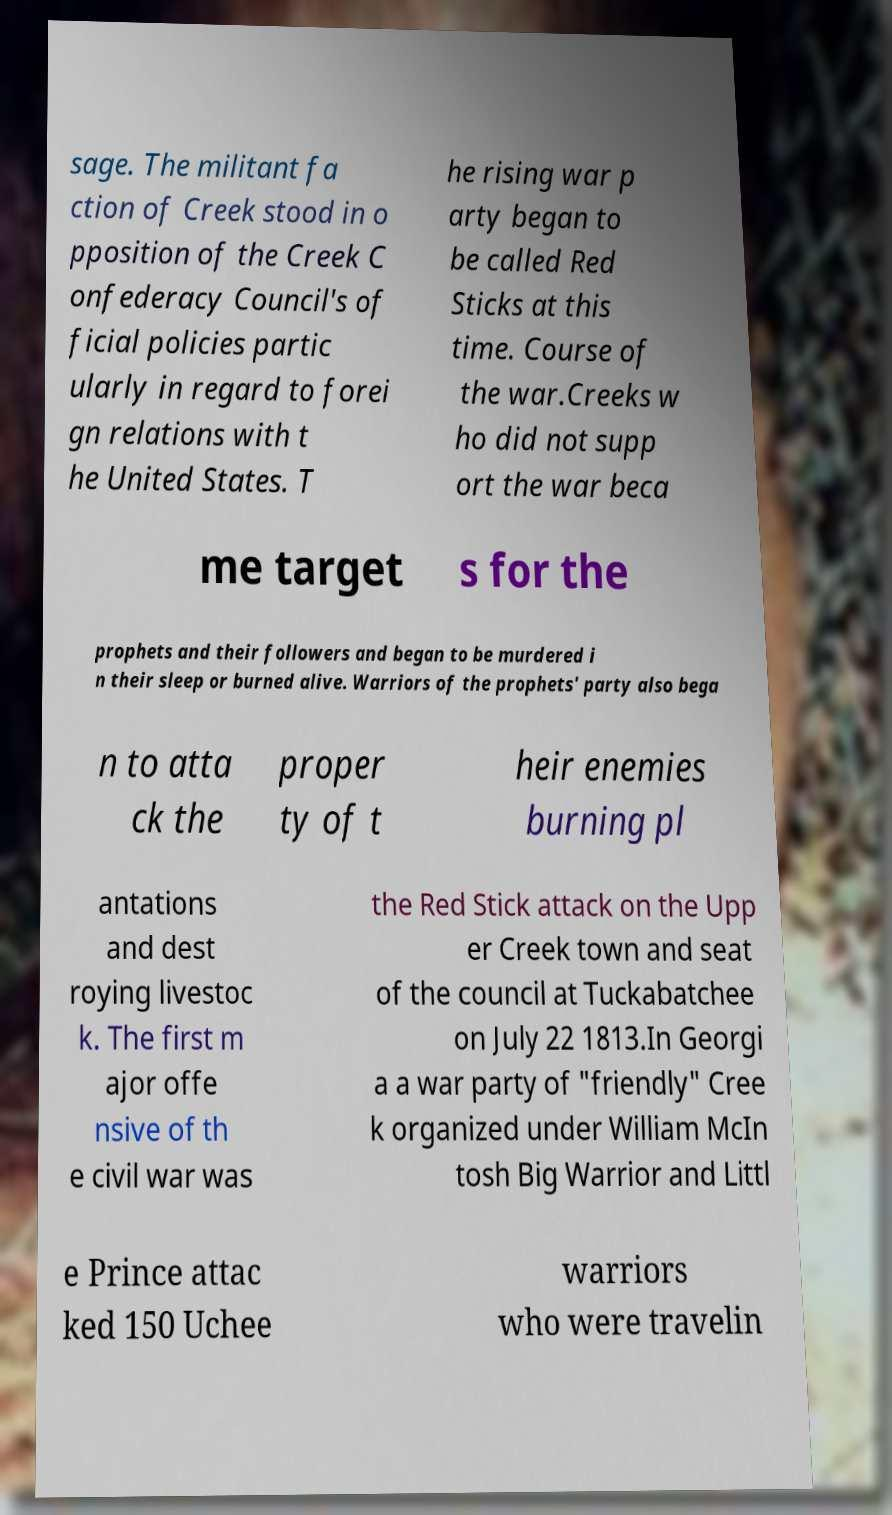I need the written content from this picture converted into text. Can you do that? sage. The militant fa ction of Creek stood in o pposition of the Creek C onfederacy Council's of ficial policies partic ularly in regard to forei gn relations with t he United States. T he rising war p arty began to be called Red Sticks at this time. Course of the war.Creeks w ho did not supp ort the war beca me target s for the prophets and their followers and began to be murdered i n their sleep or burned alive. Warriors of the prophets' party also bega n to atta ck the proper ty of t heir enemies burning pl antations and dest roying livestoc k. The first m ajor offe nsive of th e civil war was the Red Stick attack on the Upp er Creek town and seat of the council at Tuckabatchee on July 22 1813.In Georgi a a war party of "friendly" Cree k organized under William McIn tosh Big Warrior and Littl e Prince attac ked 150 Uchee warriors who were travelin 